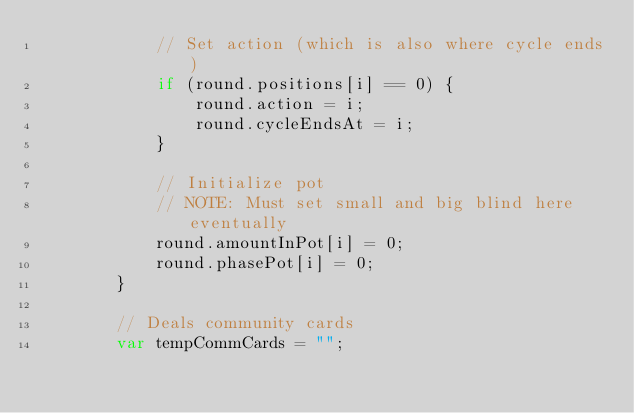<code> <loc_0><loc_0><loc_500><loc_500><_JavaScript_>            // Set action (which is also where cycle ends)
            if (round.positions[i] == 0) {
                round.action = i;
                round.cycleEndsAt = i;
            }

            // Initialize pot
            // NOTE: Must set small and big blind here eventually
            round.amountInPot[i] = 0;
            round.phasePot[i] = 0;
        }

        // Deals community cards
        var tempCommCards = "";</code> 